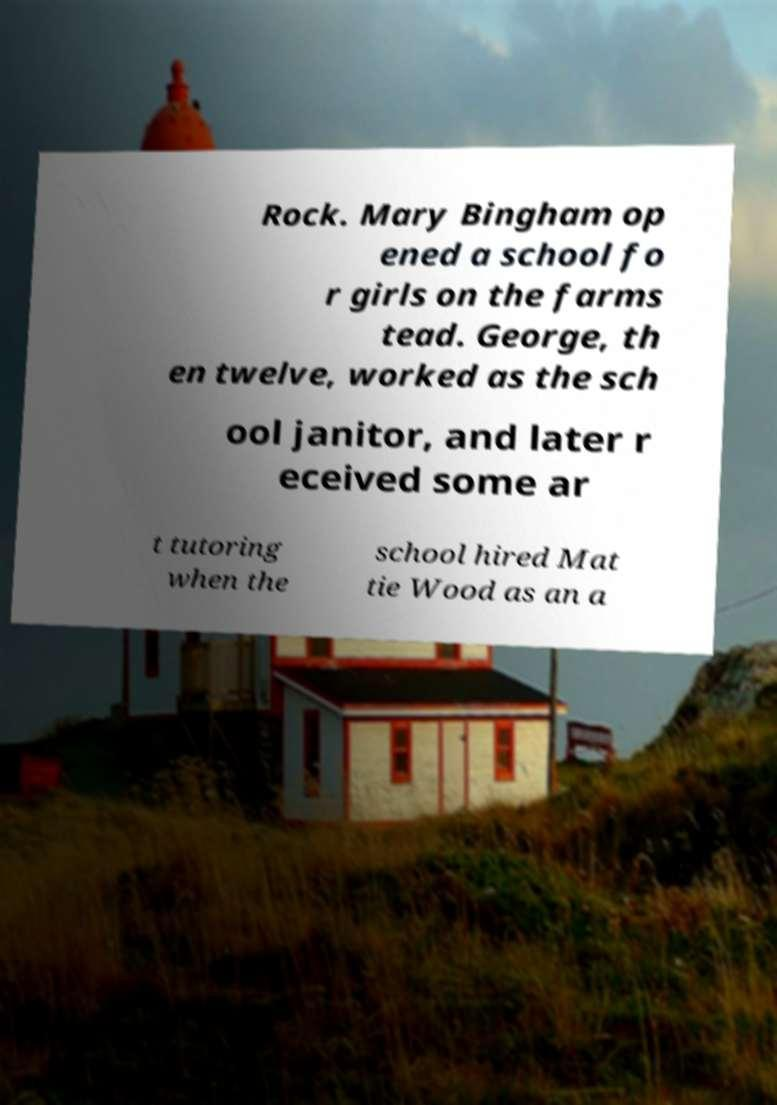Could you assist in decoding the text presented in this image and type it out clearly? Rock. Mary Bingham op ened a school fo r girls on the farms tead. George, th en twelve, worked as the sch ool janitor, and later r eceived some ar t tutoring when the school hired Mat tie Wood as an a 